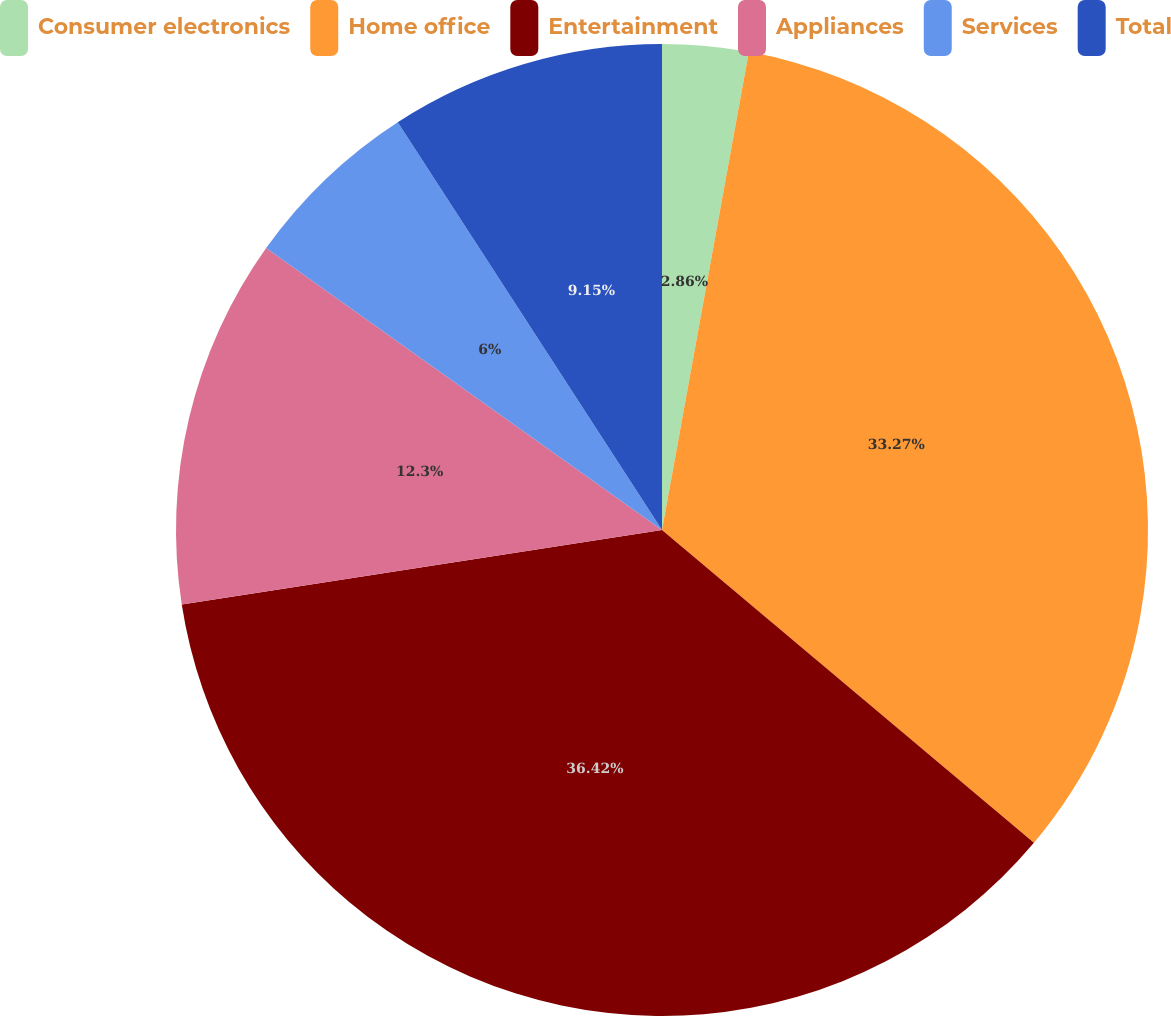Convert chart to OTSL. <chart><loc_0><loc_0><loc_500><loc_500><pie_chart><fcel>Consumer electronics<fcel>Home office<fcel>Entertainment<fcel>Appliances<fcel>Services<fcel>Total<nl><fcel>2.86%<fcel>33.27%<fcel>36.42%<fcel>12.3%<fcel>6.0%<fcel>9.15%<nl></chart> 